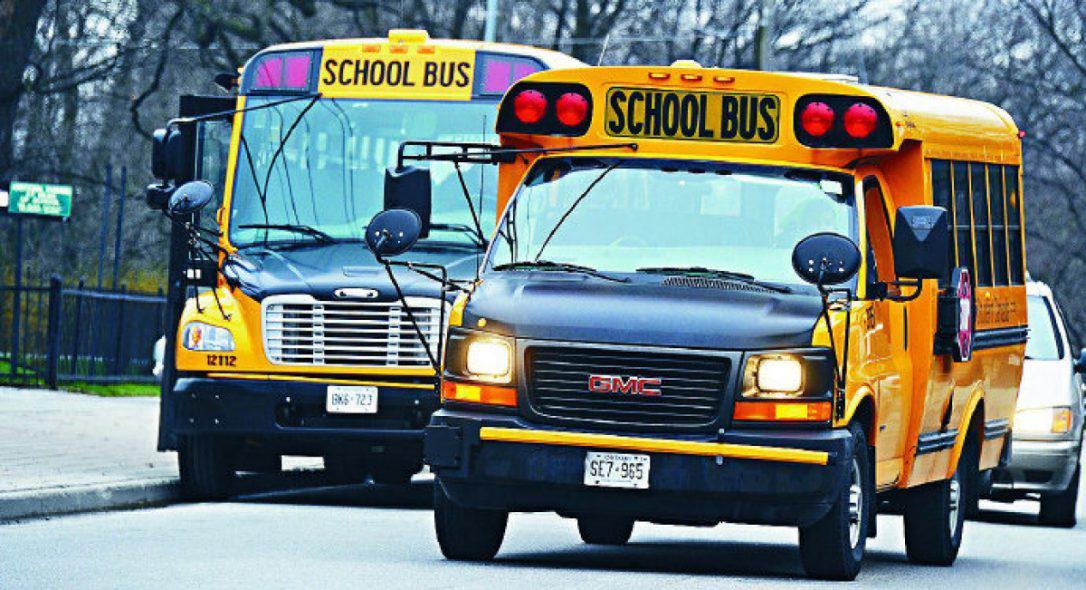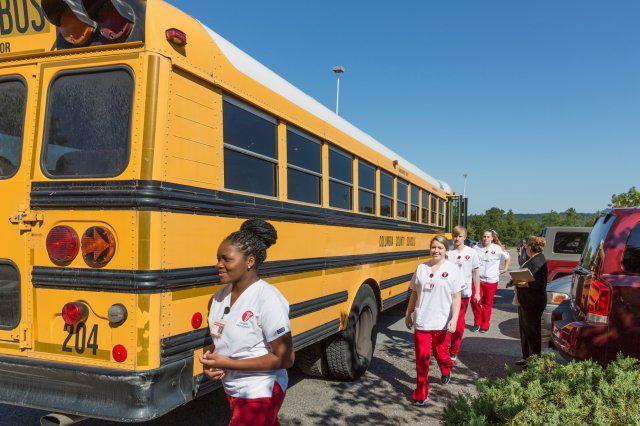The first image is the image on the left, the second image is the image on the right. Given the left and right images, does the statement "The right image includes at least one adult and at least two young children by the open doors of a bus parked diagonally facing right, and the left image shows at least two teens with backpacks to the left of a bus with an open door." hold true? Answer yes or no. No. The first image is the image on the left, the second image is the image on the right. Evaluate the accuracy of this statement regarding the images: "An officer stands outside of the bus in the image on the right.". Is it true? Answer yes or no. No. 